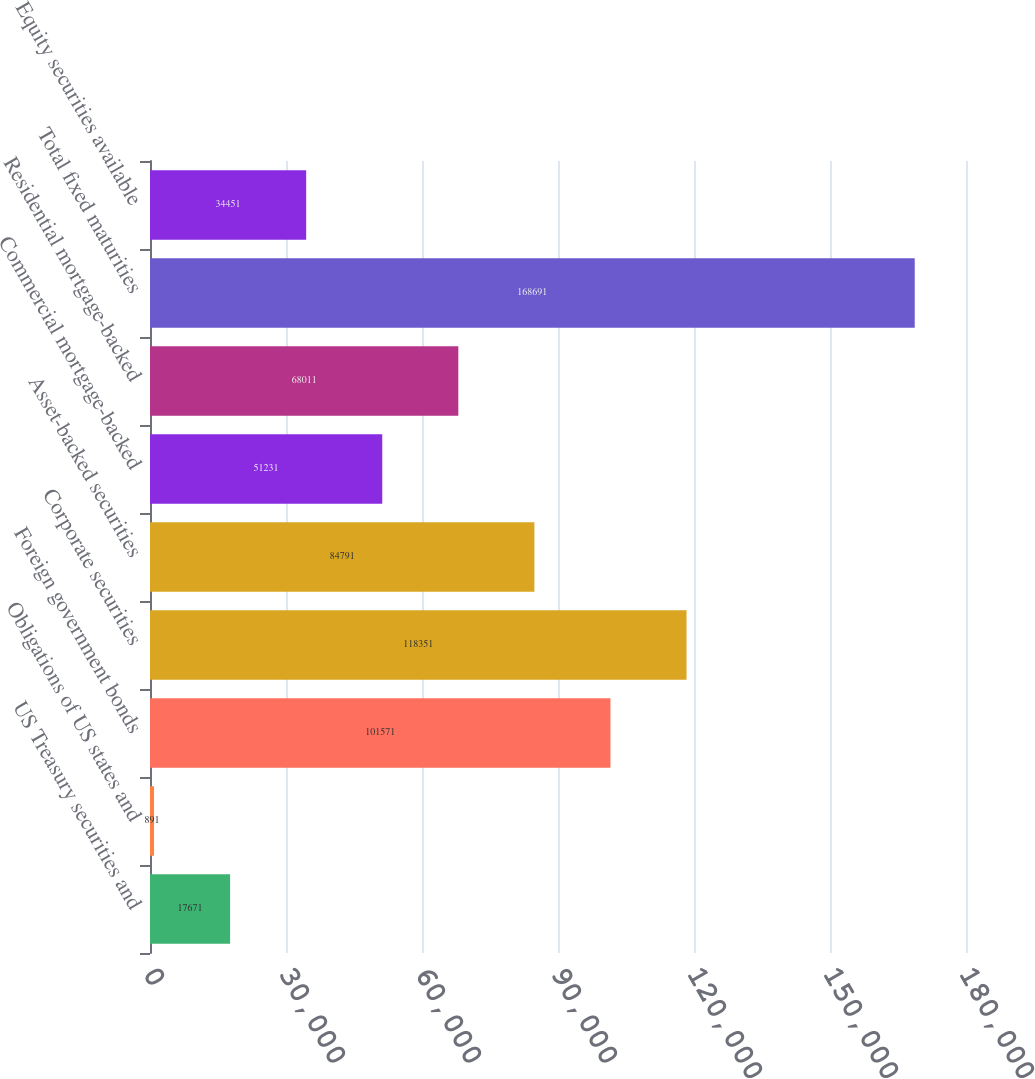Convert chart. <chart><loc_0><loc_0><loc_500><loc_500><bar_chart><fcel>US Treasury securities and<fcel>Obligations of US states and<fcel>Foreign government bonds<fcel>Corporate securities<fcel>Asset-backed securities<fcel>Commercial mortgage-backed<fcel>Residential mortgage-backed<fcel>Total fixed maturities<fcel>Equity securities available<nl><fcel>17671<fcel>891<fcel>101571<fcel>118351<fcel>84791<fcel>51231<fcel>68011<fcel>168691<fcel>34451<nl></chart> 